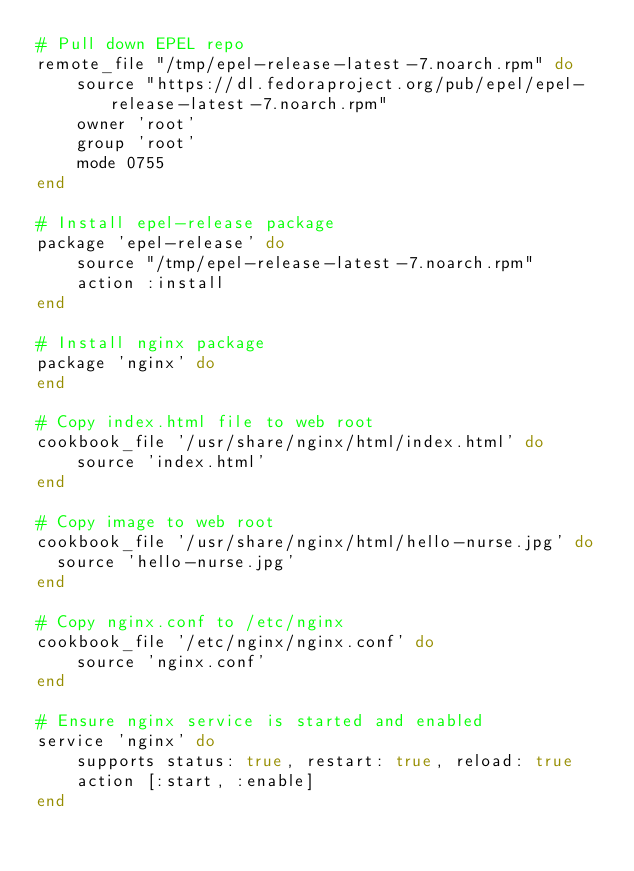<code> <loc_0><loc_0><loc_500><loc_500><_Ruby_># Pull down EPEL repo
remote_file "/tmp/epel-release-latest-7.noarch.rpm" do
    source "https://dl.fedoraproject.org/pub/epel/epel-release-latest-7.noarch.rpm"
    owner 'root'
    group 'root'
    mode 0755
end

# Install epel-release package
package 'epel-release' do
    source "/tmp/epel-release-latest-7.noarch.rpm"
    action :install
end

# Install nginx package
package 'nginx' do
end

# Copy index.html file to web root
cookbook_file '/usr/share/nginx/html/index.html' do
    source 'index.html'
end

# Copy image to web root
cookbook_file '/usr/share/nginx/html/hello-nurse.jpg' do
  source 'hello-nurse.jpg'
end

# Copy nginx.conf to /etc/nginx
cookbook_file '/etc/nginx/nginx.conf' do
    source 'nginx.conf'
end

# Ensure nginx service is started and enabled
service 'nginx' do
    supports status: true, restart: true, reload: true
    action [:start, :enable]
end</code> 